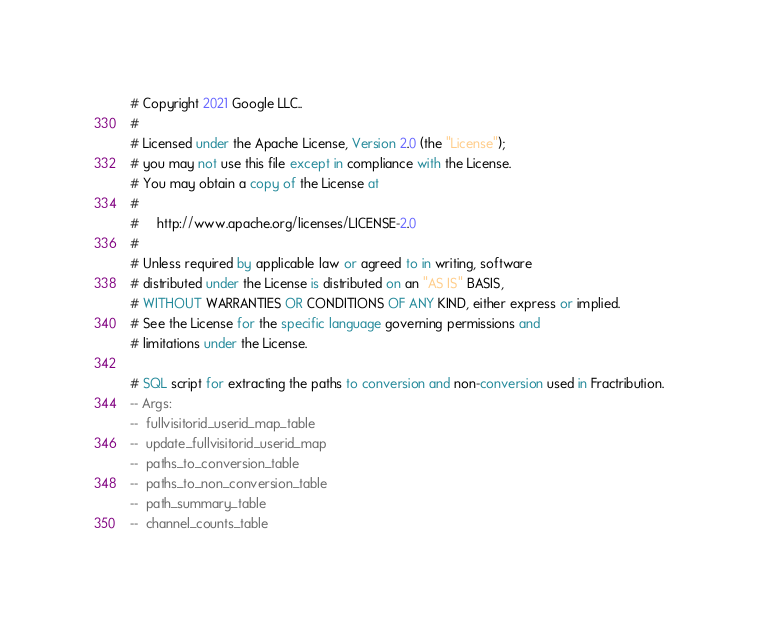<code> <loc_0><loc_0><loc_500><loc_500><_SQL_># Copyright 2021 Google LLC..
#
# Licensed under the Apache License, Version 2.0 (the "License");
# you may not use this file except in compliance with the License.
# You may obtain a copy of the License at
#
#     http://www.apache.org/licenses/LICENSE-2.0
#
# Unless required by applicable law or agreed to in writing, software
# distributed under the License is distributed on an "AS IS" BASIS,
# WITHOUT WARRANTIES OR CONDITIONS OF ANY KIND, either express or implied.
# See the License for the specific language governing permissions and
# limitations under the License.

# SQL script for extracting the paths to conversion and non-conversion used in Fractribution.
-- Args:
--  fullvisitorid_userid_map_table
--  update_fullvisitorid_userid_map
--  paths_to_conversion_table
--  paths_to_non_conversion_table
--  path_summary_table
--  channel_counts_table
</code> 